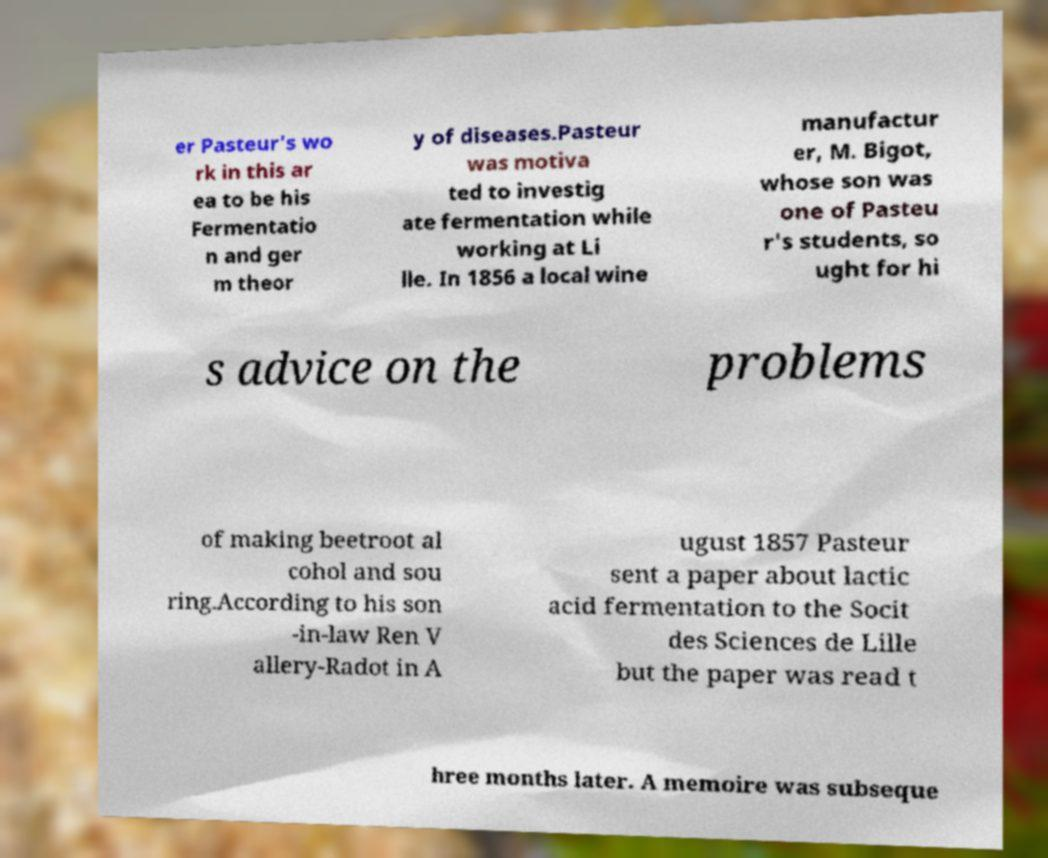Could you assist in decoding the text presented in this image and type it out clearly? er Pasteur's wo rk in this ar ea to be his Fermentatio n and ger m theor y of diseases.Pasteur was motiva ted to investig ate fermentation while working at Li lle. In 1856 a local wine manufactur er, M. Bigot, whose son was one of Pasteu r's students, so ught for hi s advice on the problems of making beetroot al cohol and sou ring.According to his son -in-law Ren V allery-Radot in A ugust 1857 Pasteur sent a paper about lactic acid fermentation to the Socit des Sciences de Lille but the paper was read t hree months later. A memoire was subseque 